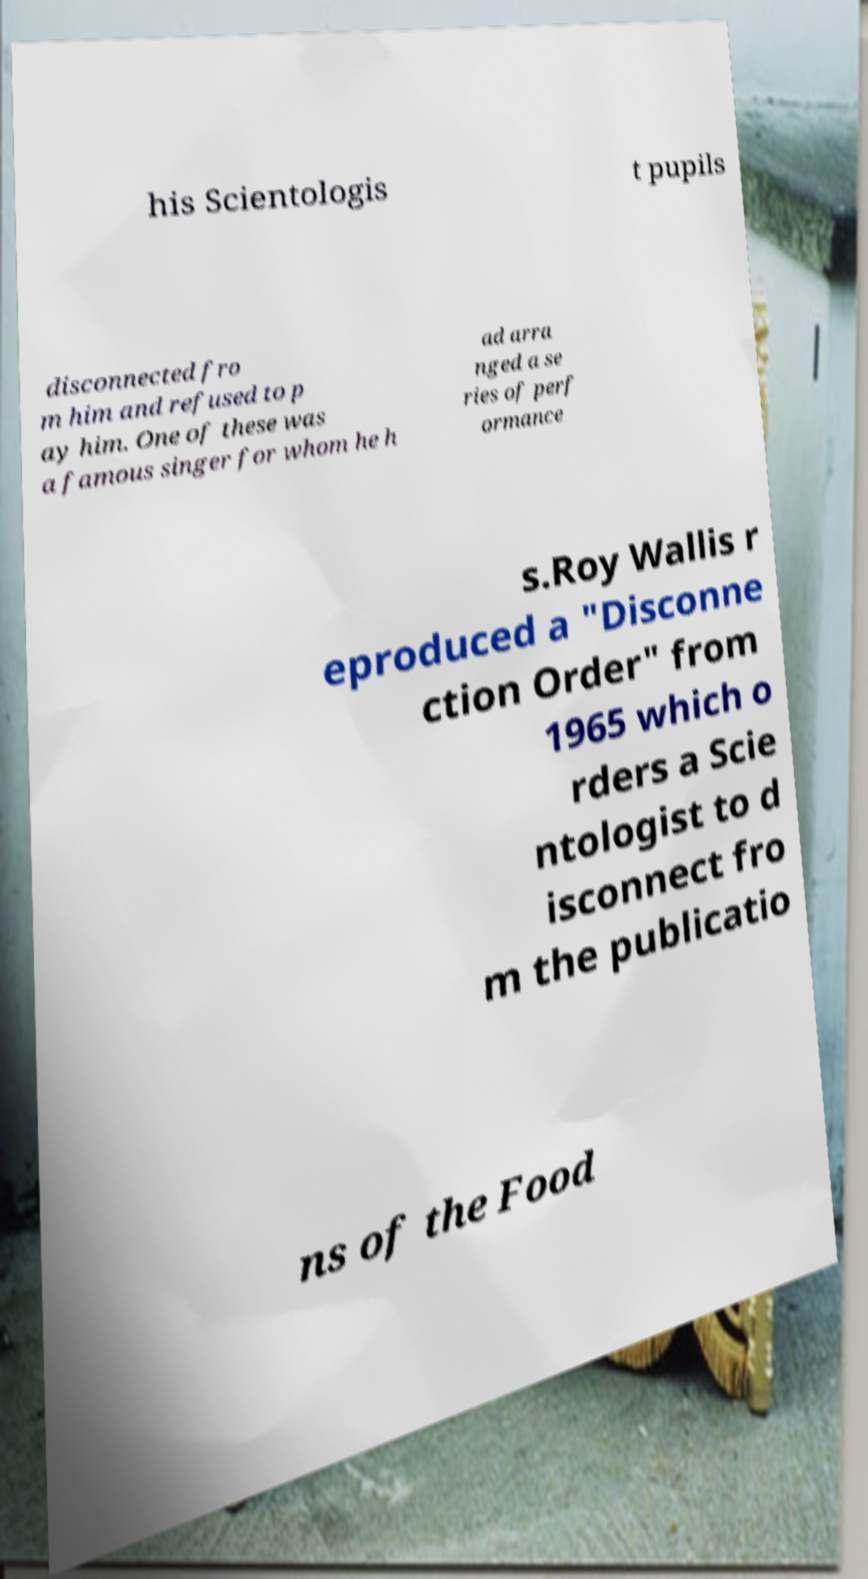Could you extract and type out the text from this image? his Scientologis t pupils disconnected fro m him and refused to p ay him. One of these was a famous singer for whom he h ad arra nged a se ries of perf ormance s.Roy Wallis r eproduced a "Disconne ction Order" from 1965 which o rders a Scie ntologist to d isconnect fro m the publicatio ns of the Food 